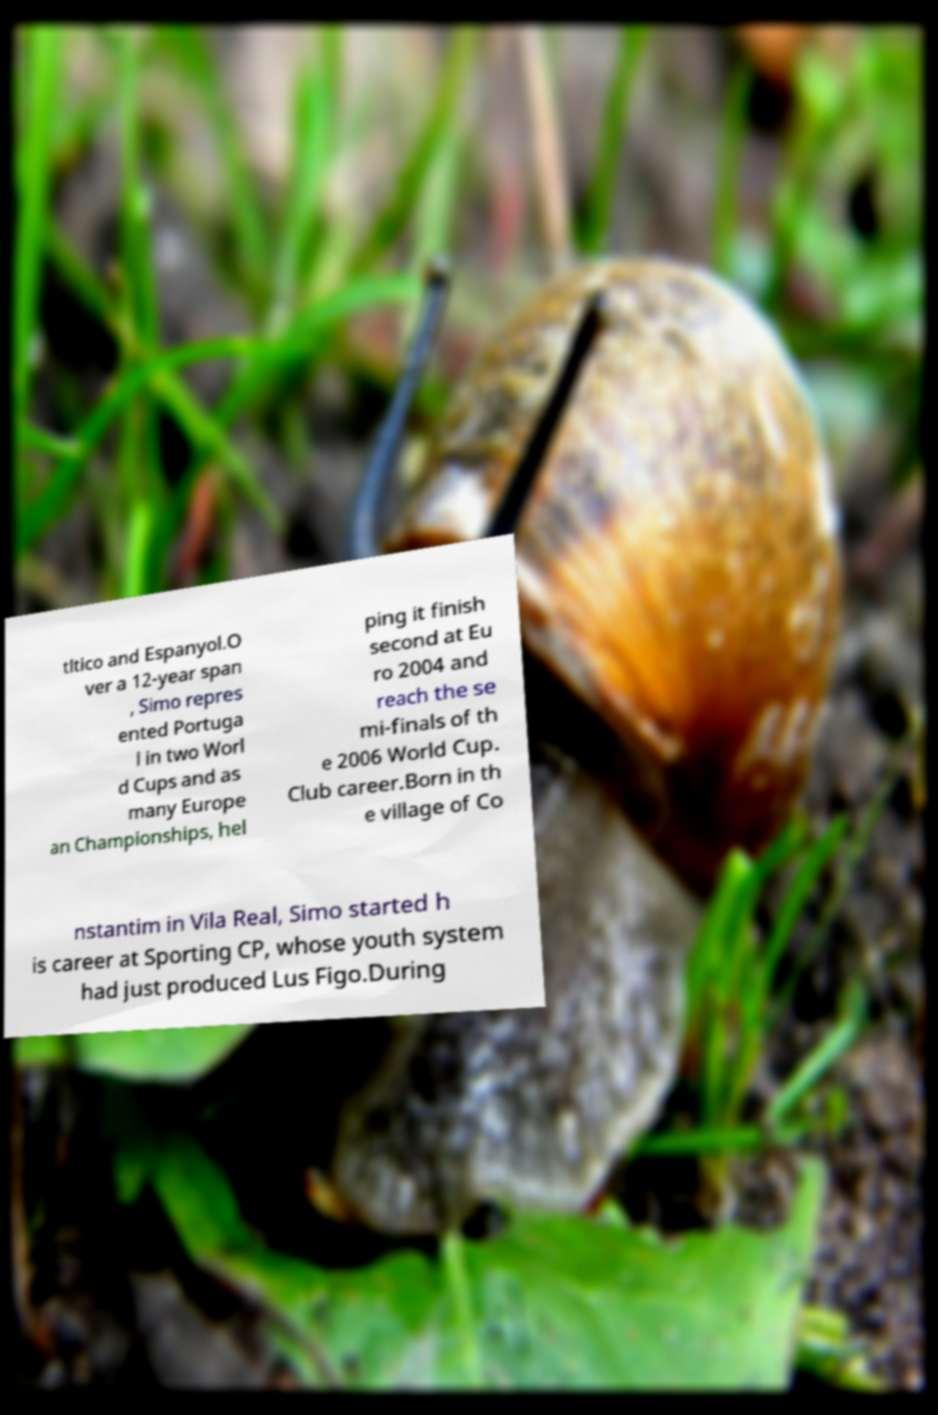Can you accurately transcribe the text from the provided image for me? tltico and Espanyol.O ver a 12-year span , Simo repres ented Portuga l in two Worl d Cups and as many Europe an Championships, hel ping it finish second at Eu ro 2004 and reach the se mi-finals of th e 2006 World Cup. Club career.Born in th e village of Co nstantim in Vila Real, Simo started h is career at Sporting CP, whose youth system had just produced Lus Figo.During 